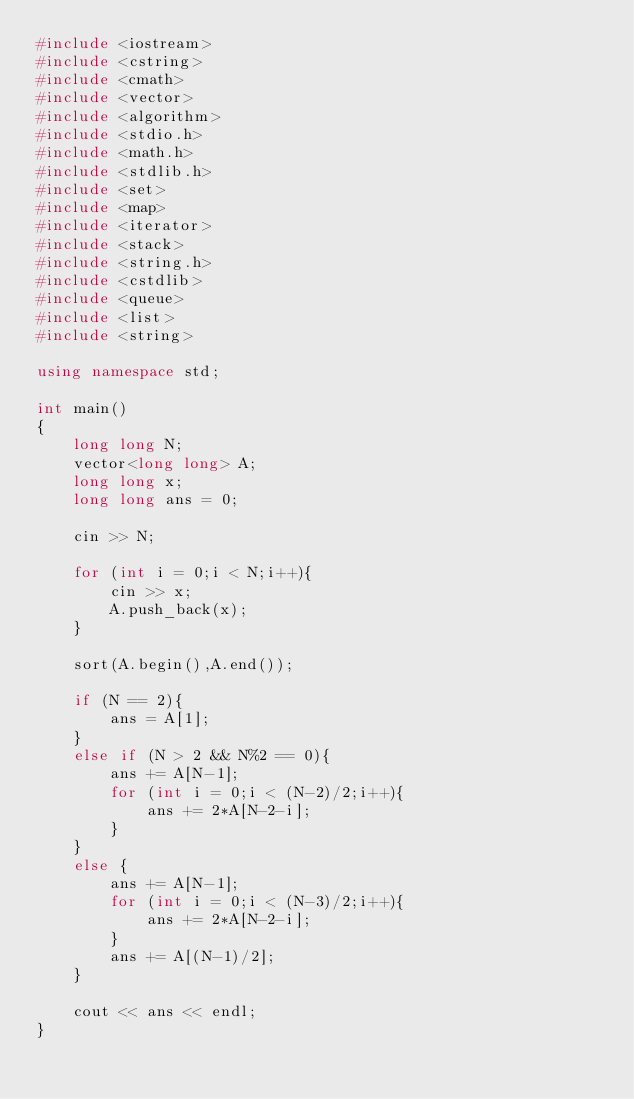<code> <loc_0><loc_0><loc_500><loc_500><_C++_>#include <iostream>
#include <cstring>
#include <cmath>
#include <vector>
#include <algorithm>
#include <stdio.h>
#include <math.h>
#include <stdlib.h>
#include <set>
#include <map>
#include <iterator>
#include <stack>
#include <string.h>
#include <cstdlib>
#include <queue>
#include <list>
#include <string>

using namespace std;

int main()
{
    long long N;
    vector<long long> A;
    long long x;
    long long ans = 0;
    
    cin >> N;
    
    for (int i = 0;i < N;i++){
        cin >> x;
        A.push_back(x);
    }
    
    sort(A.begin(),A.end());
    
    if (N == 2){
        ans = A[1];
    }
    else if (N > 2 && N%2 == 0){
        ans += A[N-1];
        for (int i = 0;i < (N-2)/2;i++){
            ans += 2*A[N-2-i];
        }
    }
    else {
        ans += A[N-1];
        for (int i = 0;i < (N-3)/2;i++){
            ans += 2*A[N-2-i];
        }
        ans += A[(N-1)/2];
    }
    
    cout << ans << endl;
}
</code> 